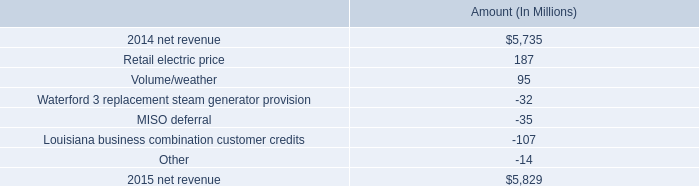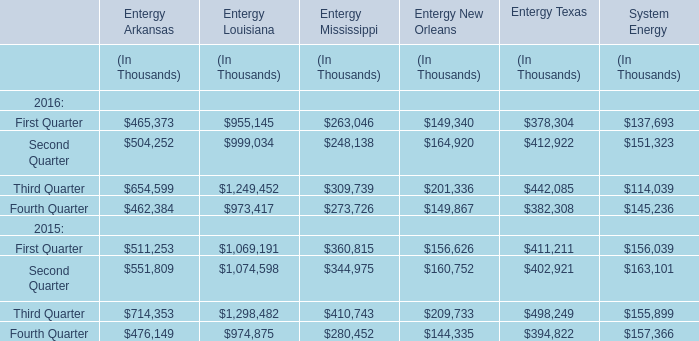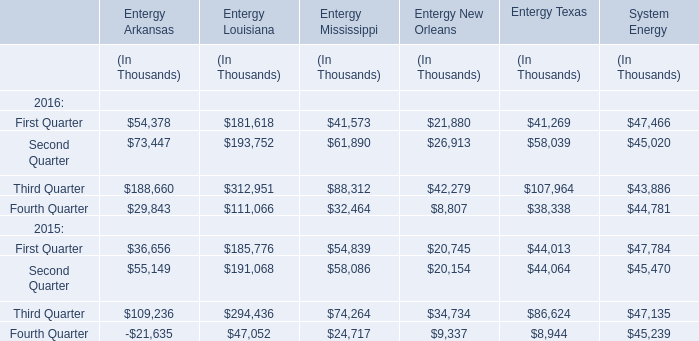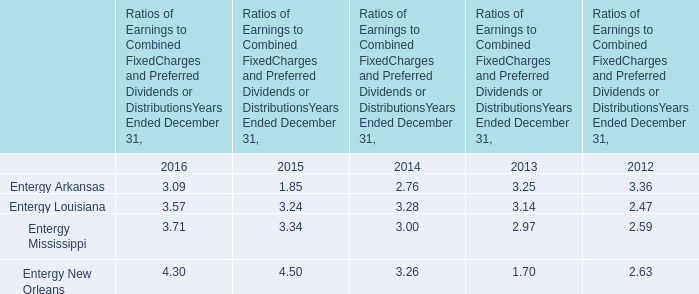What is the growing rate of Entergy Arkansas in Second Quarter in the year with the most Second Quarter? 
Computations: ((73447 - 55149) / 73447)
Answer: 0.24913. 